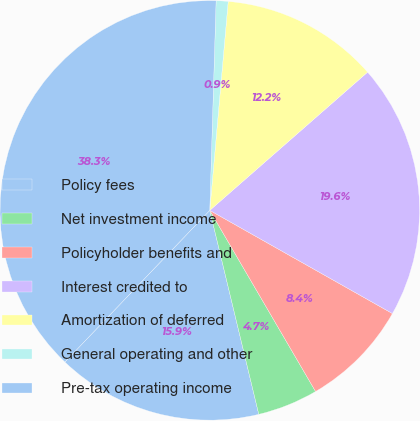Convert chart to OTSL. <chart><loc_0><loc_0><loc_500><loc_500><pie_chart><fcel>Policy fees<fcel>Net investment income<fcel>Policyholder benefits and<fcel>Interest credited to<fcel>Amortization of deferred<fcel>General operating and other<fcel>Pre-tax operating income<nl><fcel>15.89%<fcel>4.66%<fcel>8.4%<fcel>19.63%<fcel>12.15%<fcel>0.92%<fcel>38.34%<nl></chart> 